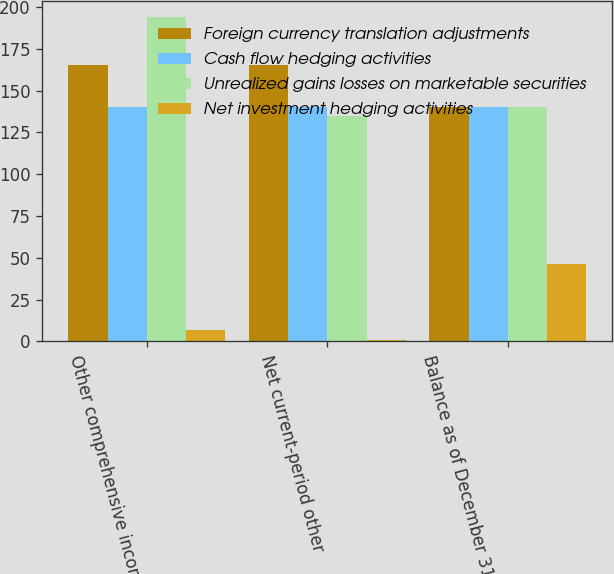Convert chart to OTSL. <chart><loc_0><loc_0><loc_500><loc_500><stacked_bar_chart><ecel><fcel>Other comprehensive income<fcel>Net current-period other<fcel>Balance as of December 31 2016<nl><fcel>Foreign currency translation adjustments<fcel>165<fcel>165<fcel>140<nl><fcel>Cash flow hedging activities<fcel>140<fcel>140<fcel>140<nl><fcel>Unrealized gains losses on marketable securities<fcel>194<fcel>135<fcel>140<nl><fcel>Net investment hedging activities<fcel>7<fcel>1<fcel>46<nl></chart> 